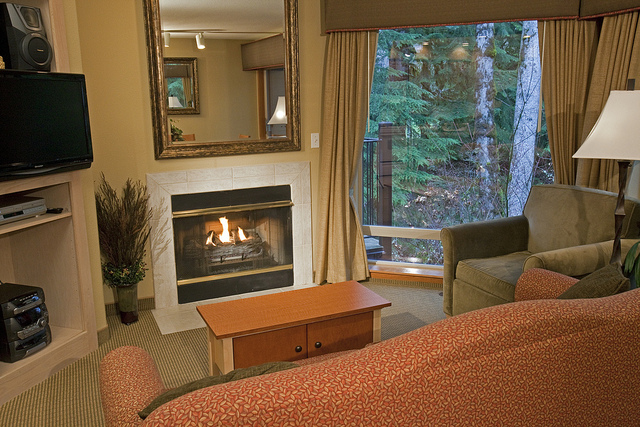<image>Where is the white wine? There is no white wine in the image. However, it could be in the kitchen or the fridge. Where is the white wine? I am not sure where the white wine is. There is no wine in the image. 